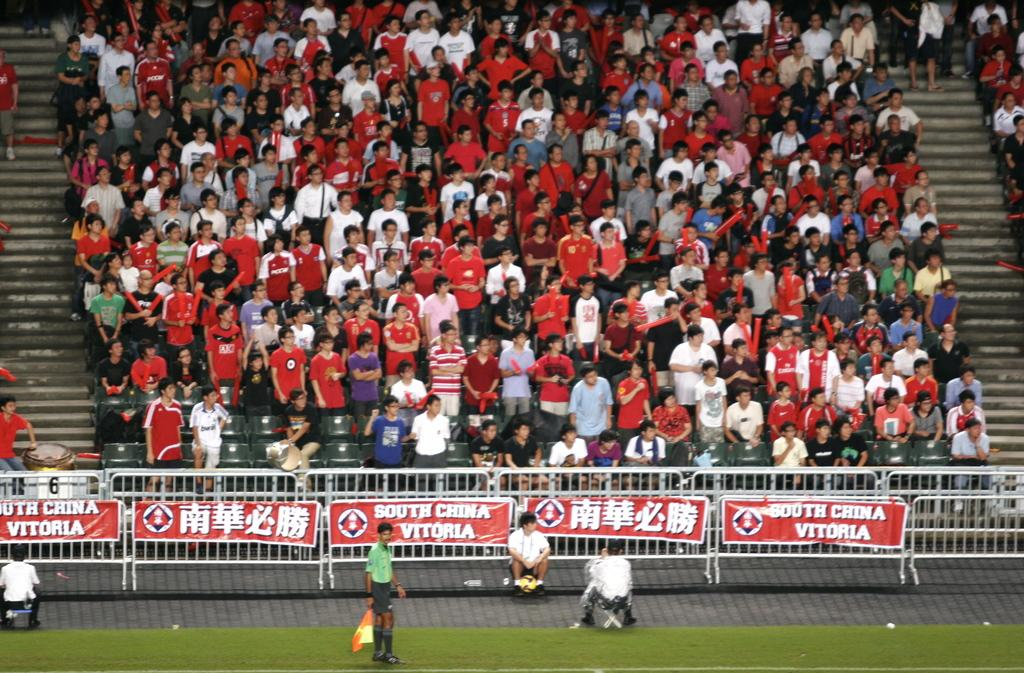Provide a one-sentence caption for the provided image. A banner on the lower right side reads "South China Vitoria.". 